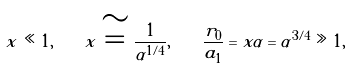<formula> <loc_0><loc_0><loc_500><loc_500>x \ll 1 , \quad x \cong \frac { 1 } { \alpha ^ { 1 / 4 } } , \quad \frac { r _ { 0 } } { a _ { 1 } } = x \alpha = \alpha ^ { 3 / 4 } \gg 1 ,</formula> 